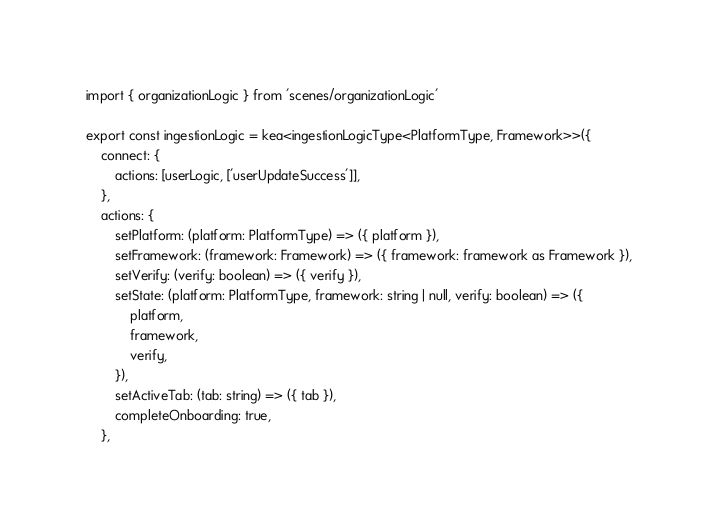Convert code to text. <code><loc_0><loc_0><loc_500><loc_500><_TypeScript_>import { organizationLogic } from 'scenes/organizationLogic'

export const ingestionLogic = kea<ingestionLogicType<PlatformType, Framework>>({
    connect: {
        actions: [userLogic, ['userUpdateSuccess']],
    },
    actions: {
        setPlatform: (platform: PlatformType) => ({ platform }),
        setFramework: (framework: Framework) => ({ framework: framework as Framework }),
        setVerify: (verify: boolean) => ({ verify }),
        setState: (platform: PlatformType, framework: string | null, verify: boolean) => ({
            platform,
            framework,
            verify,
        }),
        setActiveTab: (tab: string) => ({ tab }),
        completeOnboarding: true,
    },
</code> 